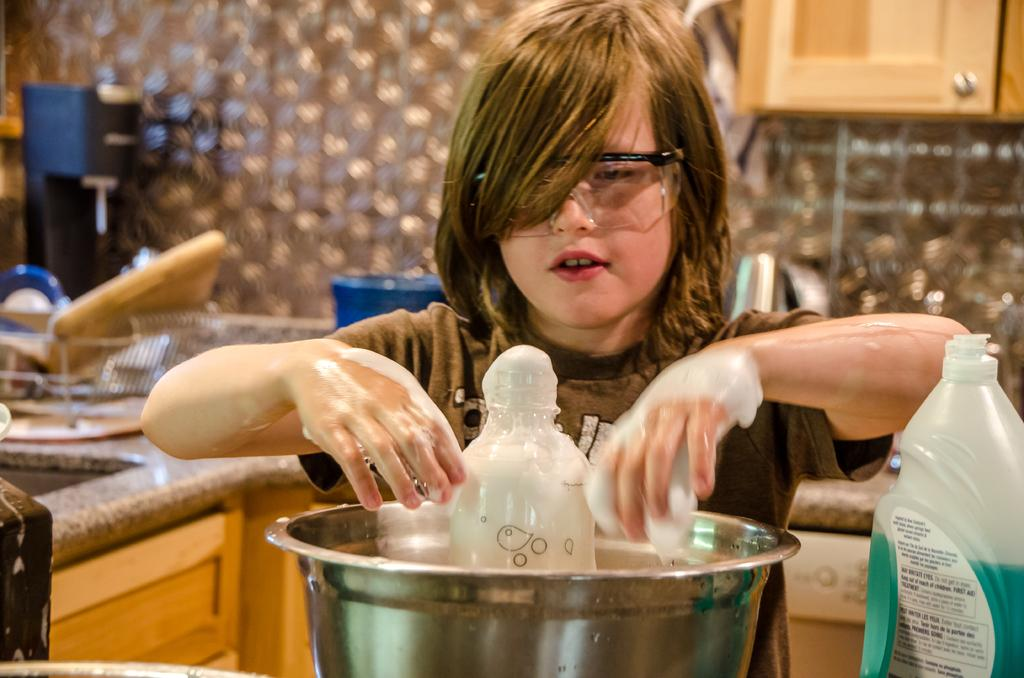Who or what is present in the image? There is a person in the image. What can be observed about the person's appearance? The person is wearing spectacles. What objects are visible in the image? There is a bowl and a bottle in the image. What can be seen in the background of the image? There is a wall in the background of the image. What type of surface is present in the image? There is a platform in the image. What type of coat is the person wearing in the image? There is no coat visible in the image; the person is wearing spectacles. What is the person's tendency towards a particular activity in the image? The image does not provide information about the person's tendencies or activities. 